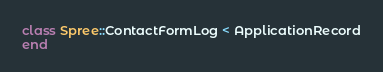<code> <loc_0><loc_0><loc_500><loc_500><_Ruby_>class Spree::ContactFormLog < ApplicationRecord
end
</code> 